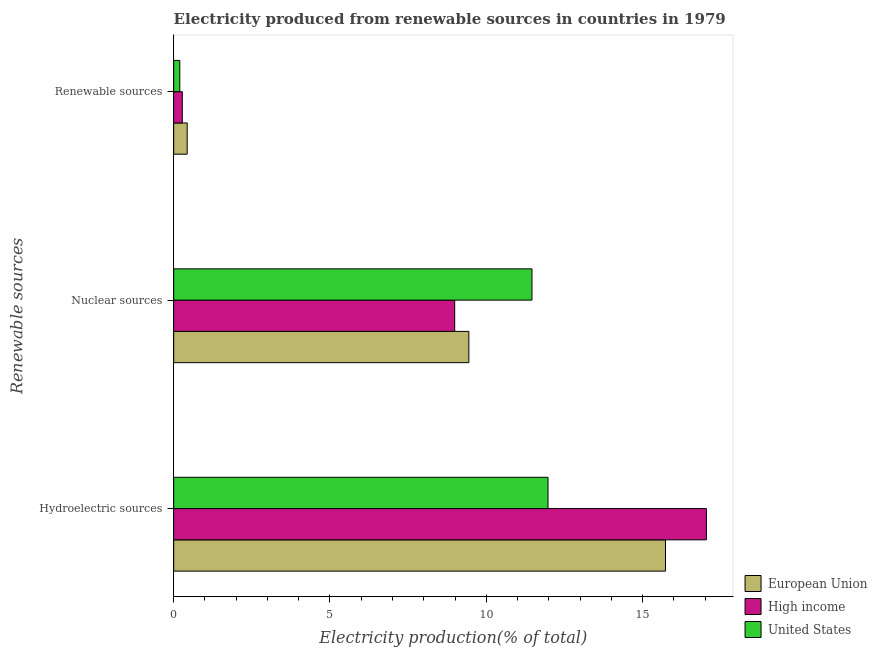How many different coloured bars are there?
Provide a short and direct response. 3. How many groups of bars are there?
Your answer should be very brief. 3. Are the number of bars per tick equal to the number of legend labels?
Provide a succinct answer. Yes. How many bars are there on the 2nd tick from the top?
Your response must be concise. 3. What is the label of the 1st group of bars from the top?
Provide a short and direct response. Renewable sources. What is the percentage of electricity produced by renewable sources in United States?
Provide a succinct answer. 0.2. Across all countries, what is the maximum percentage of electricity produced by renewable sources?
Your answer should be compact. 0.43. Across all countries, what is the minimum percentage of electricity produced by renewable sources?
Your response must be concise. 0.2. In which country was the percentage of electricity produced by hydroelectric sources minimum?
Provide a short and direct response. United States. What is the total percentage of electricity produced by nuclear sources in the graph?
Your answer should be compact. 29.9. What is the difference between the percentage of electricity produced by nuclear sources in United States and that in European Union?
Your answer should be compact. 2.02. What is the difference between the percentage of electricity produced by renewable sources in High income and the percentage of electricity produced by hydroelectric sources in United States?
Provide a succinct answer. -11.7. What is the average percentage of electricity produced by hydroelectric sources per country?
Provide a succinct answer. 14.92. What is the difference between the percentage of electricity produced by hydroelectric sources and percentage of electricity produced by renewable sources in European Union?
Your response must be concise. 15.3. In how many countries, is the percentage of electricity produced by renewable sources greater than 15 %?
Your response must be concise. 0. What is the ratio of the percentage of electricity produced by nuclear sources in European Union to that in High income?
Make the answer very short. 1.05. What is the difference between the highest and the second highest percentage of electricity produced by nuclear sources?
Your answer should be very brief. 2.02. What is the difference between the highest and the lowest percentage of electricity produced by renewable sources?
Offer a terse response. 0.24. In how many countries, is the percentage of electricity produced by renewable sources greater than the average percentage of electricity produced by renewable sources taken over all countries?
Give a very brief answer. 1. What does the 1st bar from the bottom in Renewable sources represents?
Your answer should be compact. European Union. How many bars are there?
Make the answer very short. 9. Are all the bars in the graph horizontal?
Your answer should be very brief. Yes. Does the graph contain any zero values?
Keep it short and to the point. No. Where does the legend appear in the graph?
Offer a very short reply. Bottom right. How are the legend labels stacked?
Give a very brief answer. Vertical. What is the title of the graph?
Provide a short and direct response. Electricity produced from renewable sources in countries in 1979. Does "Maldives" appear as one of the legend labels in the graph?
Make the answer very short. No. What is the label or title of the Y-axis?
Your answer should be very brief. Renewable sources. What is the Electricity production(% of total) of European Union in Hydroelectric sources?
Provide a short and direct response. 15.73. What is the Electricity production(% of total) of High income in Hydroelectric sources?
Provide a succinct answer. 17.04. What is the Electricity production(% of total) in United States in Hydroelectric sources?
Provide a short and direct response. 11.98. What is the Electricity production(% of total) in European Union in Nuclear sources?
Provide a succinct answer. 9.44. What is the Electricity production(% of total) of High income in Nuclear sources?
Provide a short and direct response. 8.99. What is the Electricity production(% of total) in United States in Nuclear sources?
Ensure brevity in your answer.  11.46. What is the Electricity production(% of total) in European Union in Renewable sources?
Keep it short and to the point. 0.43. What is the Electricity production(% of total) of High income in Renewable sources?
Your response must be concise. 0.28. What is the Electricity production(% of total) of United States in Renewable sources?
Provide a short and direct response. 0.2. Across all Renewable sources, what is the maximum Electricity production(% of total) of European Union?
Provide a succinct answer. 15.73. Across all Renewable sources, what is the maximum Electricity production(% of total) of High income?
Offer a terse response. 17.04. Across all Renewable sources, what is the maximum Electricity production(% of total) in United States?
Make the answer very short. 11.98. Across all Renewable sources, what is the minimum Electricity production(% of total) of European Union?
Provide a short and direct response. 0.43. Across all Renewable sources, what is the minimum Electricity production(% of total) of High income?
Provide a succinct answer. 0.28. Across all Renewable sources, what is the minimum Electricity production(% of total) of United States?
Provide a succinct answer. 0.2. What is the total Electricity production(% of total) of European Union in the graph?
Your response must be concise. 25.61. What is the total Electricity production(% of total) in High income in the graph?
Ensure brevity in your answer.  26.31. What is the total Electricity production(% of total) in United States in the graph?
Provide a succinct answer. 23.63. What is the difference between the Electricity production(% of total) in European Union in Hydroelectric sources and that in Nuclear sources?
Keep it short and to the point. 6.29. What is the difference between the Electricity production(% of total) of High income in Hydroelectric sources and that in Nuclear sources?
Provide a succinct answer. 8.05. What is the difference between the Electricity production(% of total) of United States in Hydroelectric sources and that in Nuclear sources?
Provide a short and direct response. 0.51. What is the difference between the Electricity production(% of total) in European Union in Hydroelectric sources and that in Renewable sources?
Offer a very short reply. 15.3. What is the difference between the Electricity production(% of total) in High income in Hydroelectric sources and that in Renewable sources?
Make the answer very short. 16.77. What is the difference between the Electricity production(% of total) of United States in Hydroelectric sources and that in Renewable sources?
Offer a very short reply. 11.78. What is the difference between the Electricity production(% of total) of European Union in Nuclear sources and that in Renewable sources?
Provide a succinct answer. 9.01. What is the difference between the Electricity production(% of total) of High income in Nuclear sources and that in Renewable sources?
Provide a short and direct response. 8.71. What is the difference between the Electricity production(% of total) in United States in Nuclear sources and that in Renewable sources?
Give a very brief answer. 11.27. What is the difference between the Electricity production(% of total) in European Union in Hydroelectric sources and the Electricity production(% of total) in High income in Nuclear sources?
Provide a short and direct response. 6.74. What is the difference between the Electricity production(% of total) in European Union in Hydroelectric sources and the Electricity production(% of total) in United States in Nuclear sources?
Offer a very short reply. 4.27. What is the difference between the Electricity production(% of total) of High income in Hydroelectric sources and the Electricity production(% of total) of United States in Nuclear sources?
Offer a very short reply. 5.58. What is the difference between the Electricity production(% of total) in European Union in Hydroelectric sources and the Electricity production(% of total) in High income in Renewable sources?
Make the answer very short. 15.46. What is the difference between the Electricity production(% of total) in European Union in Hydroelectric sources and the Electricity production(% of total) in United States in Renewable sources?
Offer a terse response. 15.54. What is the difference between the Electricity production(% of total) in High income in Hydroelectric sources and the Electricity production(% of total) in United States in Renewable sources?
Offer a very short reply. 16.85. What is the difference between the Electricity production(% of total) in European Union in Nuclear sources and the Electricity production(% of total) in High income in Renewable sources?
Give a very brief answer. 9.17. What is the difference between the Electricity production(% of total) of European Union in Nuclear sources and the Electricity production(% of total) of United States in Renewable sources?
Offer a very short reply. 9.25. What is the difference between the Electricity production(% of total) of High income in Nuclear sources and the Electricity production(% of total) of United States in Renewable sources?
Keep it short and to the point. 8.79. What is the average Electricity production(% of total) of European Union per Renewable sources?
Keep it short and to the point. 8.54. What is the average Electricity production(% of total) of High income per Renewable sources?
Provide a succinct answer. 8.77. What is the average Electricity production(% of total) of United States per Renewable sources?
Your response must be concise. 7.88. What is the difference between the Electricity production(% of total) of European Union and Electricity production(% of total) of High income in Hydroelectric sources?
Offer a terse response. -1.31. What is the difference between the Electricity production(% of total) in European Union and Electricity production(% of total) in United States in Hydroelectric sources?
Provide a short and direct response. 3.76. What is the difference between the Electricity production(% of total) in High income and Electricity production(% of total) in United States in Hydroelectric sources?
Offer a very short reply. 5.07. What is the difference between the Electricity production(% of total) in European Union and Electricity production(% of total) in High income in Nuclear sources?
Give a very brief answer. 0.45. What is the difference between the Electricity production(% of total) of European Union and Electricity production(% of total) of United States in Nuclear sources?
Ensure brevity in your answer.  -2.02. What is the difference between the Electricity production(% of total) of High income and Electricity production(% of total) of United States in Nuclear sources?
Make the answer very short. -2.47. What is the difference between the Electricity production(% of total) in European Union and Electricity production(% of total) in High income in Renewable sources?
Give a very brief answer. 0.16. What is the difference between the Electricity production(% of total) in European Union and Electricity production(% of total) in United States in Renewable sources?
Keep it short and to the point. 0.24. What is the difference between the Electricity production(% of total) in High income and Electricity production(% of total) in United States in Renewable sources?
Your response must be concise. 0.08. What is the ratio of the Electricity production(% of total) in European Union in Hydroelectric sources to that in Nuclear sources?
Provide a succinct answer. 1.67. What is the ratio of the Electricity production(% of total) of High income in Hydroelectric sources to that in Nuclear sources?
Provide a short and direct response. 1.9. What is the ratio of the Electricity production(% of total) of United States in Hydroelectric sources to that in Nuclear sources?
Offer a terse response. 1.04. What is the ratio of the Electricity production(% of total) in European Union in Hydroelectric sources to that in Renewable sources?
Offer a terse response. 36.41. What is the ratio of the Electricity production(% of total) of High income in Hydroelectric sources to that in Renewable sources?
Keep it short and to the point. 61.64. What is the ratio of the Electricity production(% of total) of United States in Hydroelectric sources to that in Renewable sources?
Give a very brief answer. 61.06. What is the ratio of the Electricity production(% of total) of European Union in Nuclear sources to that in Renewable sources?
Offer a very short reply. 21.85. What is the ratio of the Electricity production(% of total) of High income in Nuclear sources to that in Renewable sources?
Keep it short and to the point. 32.52. What is the ratio of the Electricity production(% of total) in United States in Nuclear sources to that in Renewable sources?
Give a very brief answer. 58.44. What is the difference between the highest and the second highest Electricity production(% of total) in European Union?
Give a very brief answer. 6.29. What is the difference between the highest and the second highest Electricity production(% of total) in High income?
Keep it short and to the point. 8.05. What is the difference between the highest and the second highest Electricity production(% of total) in United States?
Your answer should be compact. 0.51. What is the difference between the highest and the lowest Electricity production(% of total) in European Union?
Offer a very short reply. 15.3. What is the difference between the highest and the lowest Electricity production(% of total) of High income?
Make the answer very short. 16.77. What is the difference between the highest and the lowest Electricity production(% of total) of United States?
Ensure brevity in your answer.  11.78. 